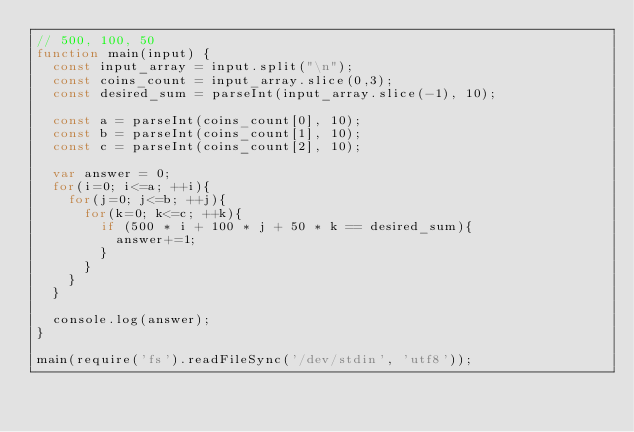<code> <loc_0><loc_0><loc_500><loc_500><_JavaScript_>// 500, 100, 50
function main(input) {
  const input_array = input.split("\n");
  const coins_count = input_array.slice(0,3);
  const desired_sum = parseInt(input_array.slice(-1), 10);

  const a = parseInt(coins_count[0], 10);
  const b = parseInt(coins_count[1], 10);
  const c = parseInt(coins_count[2], 10);
  
  var answer = 0;
  for(i=0; i<=a; ++i){
    for(j=0; j<=b; ++j){
      for(k=0; k<=c; ++k){
        if (500 * i + 100 * j + 50 * k == desired_sum){
          answer+=1;
        }
      }
    }
  }
  
  console.log(answer);
}
 
main(require('fs').readFileSync('/dev/stdin', 'utf8'));
</code> 